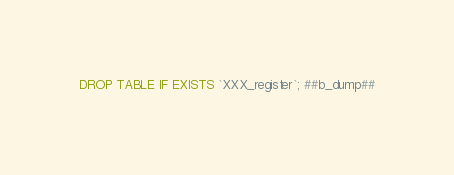<code> <loc_0><loc_0><loc_500><loc_500><_SQL_>DROP TABLE IF EXISTS `XXX_register`; ##b_dump##
</code> 